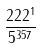<formula> <loc_0><loc_0><loc_500><loc_500>\frac { 2 2 2 ^ { 1 } } { 5 ^ { 3 5 7 } }</formula> 